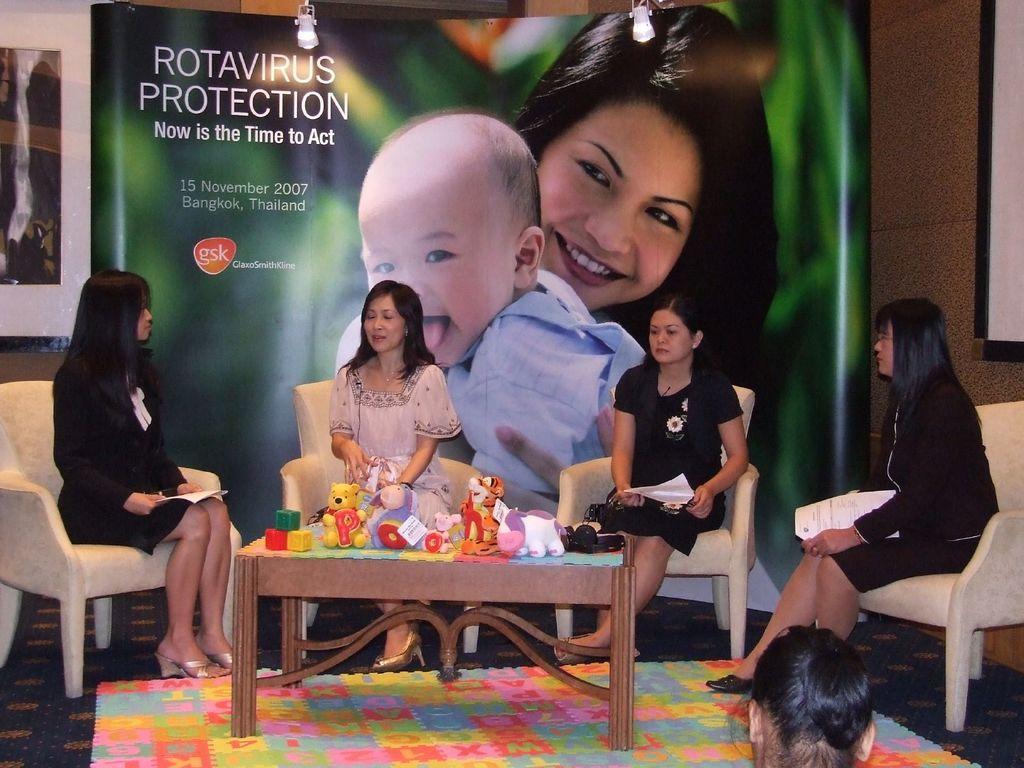Can you describe this image briefly? Here we see four people seated on chairs and we see a table with the toys on it and we see a poster of a woman and a baby on the back. 